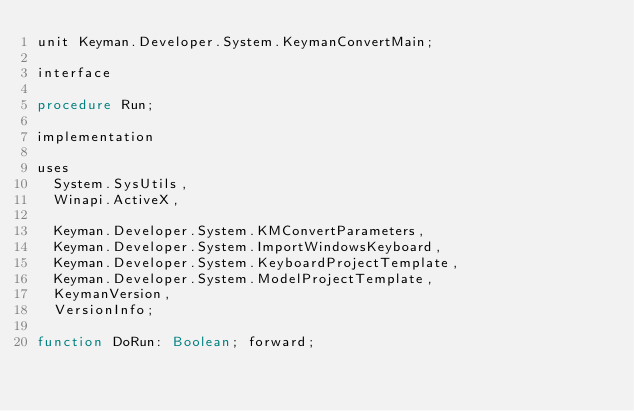Convert code to text. <code><loc_0><loc_0><loc_500><loc_500><_Pascal_>unit Keyman.Developer.System.KeymanConvertMain;

interface

procedure Run;

implementation

uses
  System.SysUtils,
  Winapi.ActiveX,

  Keyman.Developer.System.KMConvertParameters,
  Keyman.Developer.System.ImportWindowsKeyboard,
  Keyman.Developer.System.KeyboardProjectTemplate,
  Keyman.Developer.System.ModelProjectTemplate,
  KeymanVersion,
  VersionInfo;

function DoRun: Boolean; forward;
</code> 